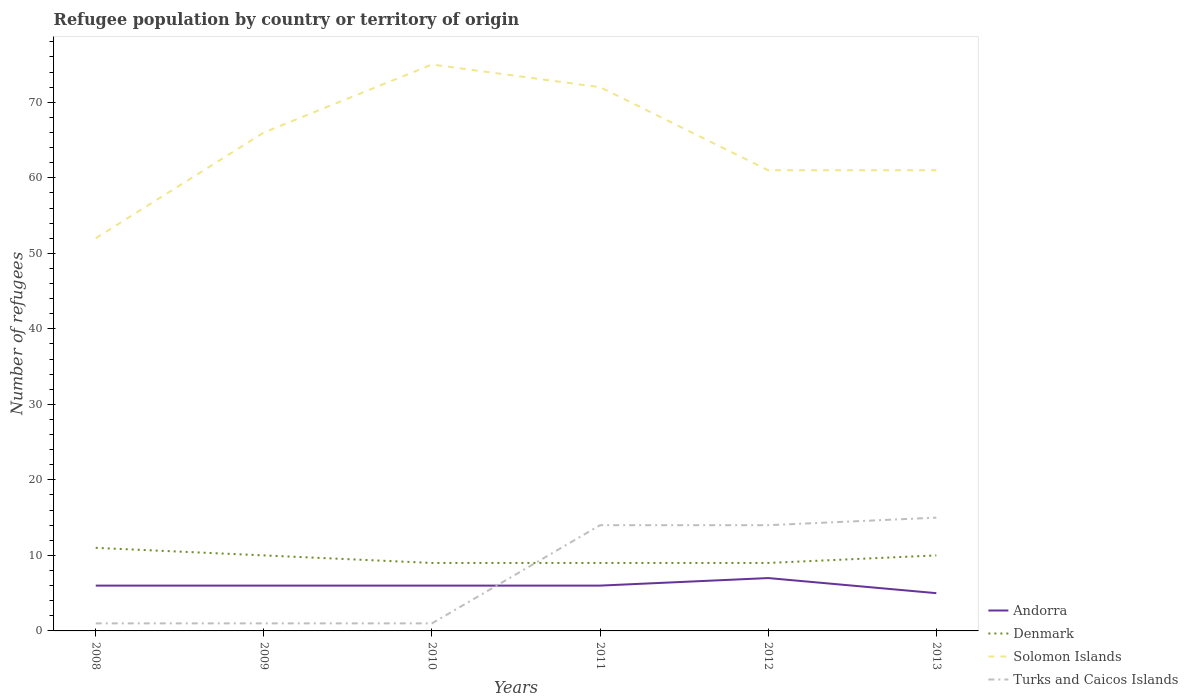Across all years, what is the maximum number of refugees in Turks and Caicos Islands?
Offer a terse response. 1. What is the difference between the highest and the lowest number of refugees in Turks and Caicos Islands?
Offer a terse response. 3. How many years are there in the graph?
Offer a very short reply. 6. What is the difference between two consecutive major ticks on the Y-axis?
Your answer should be compact. 10. How many legend labels are there?
Make the answer very short. 4. How are the legend labels stacked?
Offer a very short reply. Vertical. What is the title of the graph?
Ensure brevity in your answer.  Refugee population by country or territory of origin. What is the label or title of the X-axis?
Your response must be concise. Years. What is the label or title of the Y-axis?
Your answer should be compact. Number of refugees. What is the Number of refugees of Denmark in 2009?
Your answer should be compact. 10. What is the Number of refugees of Solomon Islands in 2009?
Your response must be concise. 66. What is the Number of refugees in Turks and Caicos Islands in 2009?
Your answer should be very brief. 1. What is the Number of refugees in Andorra in 2010?
Give a very brief answer. 6. What is the Number of refugees of Denmark in 2010?
Ensure brevity in your answer.  9. What is the Number of refugees in Solomon Islands in 2010?
Keep it short and to the point. 75. What is the Number of refugees in Andorra in 2011?
Make the answer very short. 6. What is the Number of refugees of Andorra in 2012?
Give a very brief answer. 7. What is the Number of refugees in Denmark in 2012?
Offer a terse response. 9. What is the Number of refugees of Solomon Islands in 2012?
Offer a terse response. 61. What is the Number of refugees in Turks and Caicos Islands in 2013?
Offer a very short reply. 15. Across all years, what is the maximum Number of refugees of Denmark?
Your answer should be compact. 11. Across all years, what is the maximum Number of refugees in Turks and Caicos Islands?
Provide a succinct answer. 15. Across all years, what is the minimum Number of refugees in Andorra?
Keep it short and to the point. 5. Across all years, what is the minimum Number of refugees of Solomon Islands?
Your answer should be compact. 52. Across all years, what is the minimum Number of refugees of Turks and Caicos Islands?
Keep it short and to the point. 1. What is the total Number of refugees of Andorra in the graph?
Keep it short and to the point. 36. What is the total Number of refugees of Solomon Islands in the graph?
Keep it short and to the point. 387. What is the total Number of refugees in Turks and Caicos Islands in the graph?
Provide a succinct answer. 46. What is the difference between the Number of refugees in Denmark in 2008 and that in 2009?
Offer a very short reply. 1. What is the difference between the Number of refugees of Solomon Islands in 2008 and that in 2009?
Make the answer very short. -14. What is the difference between the Number of refugees in Andorra in 2008 and that in 2010?
Your answer should be compact. 0. What is the difference between the Number of refugees of Solomon Islands in 2008 and that in 2010?
Give a very brief answer. -23. What is the difference between the Number of refugees in Andorra in 2008 and that in 2011?
Offer a very short reply. 0. What is the difference between the Number of refugees of Denmark in 2008 and that in 2011?
Make the answer very short. 2. What is the difference between the Number of refugees of Solomon Islands in 2008 and that in 2011?
Your response must be concise. -20. What is the difference between the Number of refugees in Turks and Caicos Islands in 2008 and that in 2011?
Give a very brief answer. -13. What is the difference between the Number of refugees in Andorra in 2008 and that in 2012?
Provide a succinct answer. -1. What is the difference between the Number of refugees of Solomon Islands in 2008 and that in 2012?
Provide a short and direct response. -9. What is the difference between the Number of refugees in Turks and Caicos Islands in 2008 and that in 2012?
Your answer should be compact. -13. What is the difference between the Number of refugees of Andorra in 2008 and that in 2013?
Keep it short and to the point. 1. What is the difference between the Number of refugees of Denmark in 2008 and that in 2013?
Your response must be concise. 1. What is the difference between the Number of refugees of Turks and Caicos Islands in 2008 and that in 2013?
Provide a short and direct response. -14. What is the difference between the Number of refugees in Andorra in 2009 and that in 2010?
Offer a terse response. 0. What is the difference between the Number of refugees of Denmark in 2009 and that in 2010?
Keep it short and to the point. 1. What is the difference between the Number of refugees of Andorra in 2009 and that in 2012?
Give a very brief answer. -1. What is the difference between the Number of refugees in Andorra in 2009 and that in 2013?
Offer a very short reply. 1. What is the difference between the Number of refugees of Solomon Islands in 2009 and that in 2013?
Give a very brief answer. 5. What is the difference between the Number of refugees in Turks and Caicos Islands in 2009 and that in 2013?
Keep it short and to the point. -14. What is the difference between the Number of refugees of Solomon Islands in 2010 and that in 2011?
Your answer should be very brief. 3. What is the difference between the Number of refugees in Turks and Caicos Islands in 2010 and that in 2011?
Offer a very short reply. -13. What is the difference between the Number of refugees of Turks and Caicos Islands in 2010 and that in 2012?
Provide a short and direct response. -13. What is the difference between the Number of refugees in Denmark in 2010 and that in 2013?
Your response must be concise. -1. What is the difference between the Number of refugees in Turks and Caicos Islands in 2010 and that in 2013?
Offer a terse response. -14. What is the difference between the Number of refugees in Andorra in 2011 and that in 2012?
Provide a short and direct response. -1. What is the difference between the Number of refugees of Denmark in 2011 and that in 2012?
Your answer should be very brief. 0. What is the difference between the Number of refugees of Andorra in 2011 and that in 2013?
Offer a very short reply. 1. What is the difference between the Number of refugees in Turks and Caicos Islands in 2011 and that in 2013?
Make the answer very short. -1. What is the difference between the Number of refugees of Andorra in 2012 and that in 2013?
Give a very brief answer. 2. What is the difference between the Number of refugees of Solomon Islands in 2012 and that in 2013?
Offer a terse response. 0. What is the difference between the Number of refugees in Andorra in 2008 and the Number of refugees in Solomon Islands in 2009?
Ensure brevity in your answer.  -60. What is the difference between the Number of refugees of Denmark in 2008 and the Number of refugees of Solomon Islands in 2009?
Offer a very short reply. -55. What is the difference between the Number of refugees in Denmark in 2008 and the Number of refugees in Turks and Caicos Islands in 2009?
Give a very brief answer. 10. What is the difference between the Number of refugees of Andorra in 2008 and the Number of refugees of Solomon Islands in 2010?
Offer a very short reply. -69. What is the difference between the Number of refugees in Andorra in 2008 and the Number of refugees in Turks and Caicos Islands in 2010?
Keep it short and to the point. 5. What is the difference between the Number of refugees of Denmark in 2008 and the Number of refugees of Solomon Islands in 2010?
Provide a succinct answer. -64. What is the difference between the Number of refugees in Solomon Islands in 2008 and the Number of refugees in Turks and Caicos Islands in 2010?
Provide a short and direct response. 51. What is the difference between the Number of refugees of Andorra in 2008 and the Number of refugees of Solomon Islands in 2011?
Your answer should be compact. -66. What is the difference between the Number of refugees in Denmark in 2008 and the Number of refugees in Solomon Islands in 2011?
Ensure brevity in your answer.  -61. What is the difference between the Number of refugees in Denmark in 2008 and the Number of refugees in Turks and Caicos Islands in 2011?
Offer a very short reply. -3. What is the difference between the Number of refugees of Andorra in 2008 and the Number of refugees of Solomon Islands in 2012?
Provide a succinct answer. -55. What is the difference between the Number of refugees of Denmark in 2008 and the Number of refugees of Solomon Islands in 2012?
Provide a short and direct response. -50. What is the difference between the Number of refugees in Denmark in 2008 and the Number of refugees in Turks and Caicos Islands in 2012?
Your response must be concise. -3. What is the difference between the Number of refugees in Andorra in 2008 and the Number of refugees in Denmark in 2013?
Provide a succinct answer. -4. What is the difference between the Number of refugees of Andorra in 2008 and the Number of refugees of Solomon Islands in 2013?
Your response must be concise. -55. What is the difference between the Number of refugees in Denmark in 2008 and the Number of refugees in Turks and Caicos Islands in 2013?
Make the answer very short. -4. What is the difference between the Number of refugees in Andorra in 2009 and the Number of refugees in Denmark in 2010?
Ensure brevity in your answer.  -3. What is the difference between the Number of refugees of Andorra in 2009 and the Number of refugees of Solomon Islands in 2010?
Provide a succinct answer. -69. What is the difference between the Number of refugees in Andorra in 2009 and the Number of refugees in Turks and Caicos Islands in 2010?
Provide a succinct answer. 5. What is the difference between the Number of refugees of Denmark in 2009 and the Number of refugees of Solomon Islands in 2010?
Provide a short and direct response. -65. What is the difference between the Number of refugees in Andorra in 2009 and the Number of refugees in Denmark in 2011?
Offer a terse response. -3. What is the difference between the Number of refugees of Andorra in 2009 and the Number of refugees of Solomon Islands in 2011?
Your answer should be very brief. -66. What is the difference between the Number of refugees in Andorra in 2009 and the Number of refugees in Turks and Caicos Islands in 2011?
Give a very brief answer. -8. What is the difference between the Number of refugees in Denmark in 2009 and the Number of refugees in Solomon Islands in 2011?
Make the answer very short. -62. What is the difference between the Number of refugees in Denmark in 2009 and the Number of refugees in Turks and Caicos Islands in 2011?
Provide a short and direct response. -4. What is the difference between the Number of refugees in Andorra in 2009 and the Number of refugees in Solomon Islands in 2012?
Keep it short and to the point. -55. What is the difference between the Number of refugees in Denmark in 2009 and the Number of refugees in Solomon Islands in 2012?
Ensure brevity in your answer.  -51. What is the difference between the Number of refugees of Denmark in 2009 and the Number of refugees of Turks and Caicos Islands in 2012?
Offer a very short reply. -4. What is the difference between the Number of refugees in Andorra in 2009 and the Number of refugees in Denmark in 2013?
Your response must be concise. -4. What is the difference between the Number of refugees of Andorra in 2009 and the Number of refugees of Solomon Islands in 2013?
Provide a short and direct response. -55. What is the difference between the Number of refugees in Denmark in 2009 and the Number of refugees in Solomon Islands in 2013?
Offer a very short reply. -51. What is the difference between the Number of refugees in Denmark in 2009 and the Number of refugees in Turks and Caicos Islands in 2013?
Offer a terse response. -5. What is the difference between the Number of refugees in Solomon Islands in 2009 and the Number of refugees in Turks and Caicos Islands in 2013?
Offer a terse response. 51. What is the difference between the Number of refugees in Andorra in 2010 and the Number of refugees in Denmark in 2011?
Your response must be concise. -3. What is the difference between the Number of refugees of Andorra in 2010 and the Number of refugees of Solomon Islands in 2011?
Make the answer very short. -66. What is the difference between the Number of refugees in Denmark in 2010 and the Number of refugees in Solomon Islands in 2011?
Your answer should be compact. -63. What is the difference between the Number of refugees in Solomon Islands in 2010 and the Number of refugees in Turks and Caicos Islands in 2011?
Your answer should be compact. 61. What is the difference between the Number of refugees of Andorra in 2010 and the Number of refugees of Solomon Islands in 2012?
Ensure brevity in your answer.  -55. What is the difference between the Number of refugees of Andorra in 2010 and the Number of refugees of Turks and Caicos Islands in 2012?
Your answer should be compact. -8. What is the difference between the Number of refugees in Denmark in 2010 and the Number of refugees in Solomon Islands in 2012?
Provide a succinct answer. -52. What is the difference between the Number of refugees of Denmark in 2010 and the Number of refugees of Turks and Caicos Islands in 2012?
Offer a terse response. -5. What is the difference between the Number of refugees in Andorra in 2010 and the Number of refugees in Denmark in 2013?
Provide a succinct answer. -4. What is the difference between the Number of refugees in Andorra in 2010 and the Number of refugees in Solomon Islands in 2013?
Give a very brief answer. -55. What is the difference between the Number of refugees in Andorra in 2010 and the Number of refugees in Turks and Caicos Islands in 2013?
Make the answer very short. -9. What is the difference between the Number of refugees of Denmark in 2010 and the Number of refugees of Solomon Islands in 2013?
Your answer should be compact. -52. What is the difference between the Number of refugees of Denmark in 2010 and the Number of refugees of Turks and Caicos Islands in 2013?
Offer a very short reply. -6. What is the difference between the Number of refugees of Andorra in 2011 and the Number of refugees of Denmark in 2012?
Offer a very short reply. -3. What is the difference between the Number of refugees of Andorra in 2011 and the Number of refugees of Solomon Islands in 2012?
Provide a short and direct response. -55. What is the difference between the Number of refugees in Denmark in 2011 and the Number of refugees in Solomon Islands in 2012?
Provide a short and direct response. -52. What is the difference between the Number of refugees in Solomon Islands in 2011 and the Number of refugees in Turks and Caicos Islands in 2012?
Offer a terse response. 58. What is the difference between the Number of refugees in Andorra in 2011 and the Number of refugees in Solomon Islands in 2013?
Your response must be concise. -55. What is the difference between the Number of refugees in Andorra in 2011 and the Number of refugees in Turks and Caicos Islands in 2013?
Your answer should be compact. -9. What is the difference between the Number of refugees of Denmark in 2011 and the Number of refugees of Solomon Islands in 2013?
Keep it short and to the point. -52. What is the difference between the Number of refugees in Solomon Islands in 2011 and the Number of refugees in Turks and Caicos Islands in 2013?
Provide a short and direct response. 57. What is the difference between the Number of refugees of Andorra in 2012 and the Number of refugees of Denmark in 2013?
Your answer should be very brief. -3. What is the difference between the Number of refugees in Andorra in 2012 and the Number of refugees in Solomon Islands in 2013?
Your response must be concise. -54. What is the difference between the Number of refugees in Andorra in 2012 and the Number of refugees in Turks and Caicos Islands in 2013?
Give a very brief answer. -8. What is the difference between the Number of refugees in Denmark in 2012 and the Number of refugees in Solomon Islands in 2013?
Your answer should be compact. -52. What is the difference between the Number of refugees in Solomon Islands in 2012 and the Number of refugees in Turks and Caicos Islands in 2013?
Give a very brief answer. 46. What is the average Number of refugees of Denmark per year?
Your answer should be very brief. 9.67. What is the average Number of refugees in Solomon Islands per year?
Make the answer very short. 64.5. What is the average Number of refugees of Turks and Caicos Islands per year?
Your response must be concise. 7.67. In the year 2008, what is the difference between the Number of refugees of Andorra and Number of refugees of Solomon Islands?
Ensure brevity in your answer.  -46. In the year 2008, what is the difference between the Number of refugees of Denmark and Number of refugees of Solomon Islands?
Provide a succinct answer. -41. In the year 2009, what is the difference between the Number of refugees in Andorra and Number of refugees in Denmark?
Provide a short and direct response. -4. In the year 2009, what is the difference between the Number of refugees of Andorra and Number of refugees of Solomon Islands?
Provide a succinct answer. -60. In the year 2009, what is the difference between the Number of refugees of Denmark and Number of refugees of Solomon Islands?
Provide a short and direct response. -56. In the year 2009, what is the difference between the Number of refugees of Denmark and Number of refugees of Turks and Caicos Islands?
Keep it short and to the point. 9. In the year 2010, what is the difference between the Number of refugees in Andorra and Number of refugees in Denmark?
Give a very brief answer. -3. In the year 2010, what is the difference between the Number of refugees in Andorra and Number of refugees in Solomon Islands?
Your answer should be very brief. -69. In the year 2010, what is the difference between the Number of refugees of Andorra and Number of refugees of Turks and Caicos Islands?
Your answer should be compact. 5. In the year 2010, what is the difference between the Number of refugees in Denmark and Number of refugees in Solomon Islands?
Your answer should be compact. -66. In the year 2010, what is the difference between the Number of refugees of Solomon Islands and Number of refugees of Turks and Caicos Islands?
Make the answer very short. 74. In the year 2011, what is the difference between the Number of refugees in Andorra and Number of refugees in Denmark?
Your response must be concise. -3. In the year 2011, what is the difference between the Number of refugees of Andorra and Number of refugees of Solomon Islands?
Provide a short and direct response. -66. In the year 2011, what is the difference between the Number of refugees in Denmark and Number of refugees in Solomon Islands?
Make the answer very short. -63. In the year 2011, what is the difference between the Number of refugees in Denmark and Number of refugees in Turks and Caicos Islands?
Provide a succinct answer. -5. In the year 2011, what is the difference between the Number of refugees in Solomon Islands and Number of refugees in Turks and Caicos Islands?
Keep it short and to the point. 58. In the year 2012, what is the difference between the Number of refugees of Andorra and Number of refugees of Denmark?
Give a very brief answer. -2. In the year 2012, what is the difference between the Number of refugees of Andorra and Number of refugees of Solomon Islands?
Offer a very short reply. -54. In the year 2012, what is the difference between the Number of refugees in Andorra and Number of refugees in Turks and Caicos Islands?
Your answer should be compact. -7. In the year 2012, what is the difference between the Number of refugees of Denmark and Number of refugees of Solomon Islands?
Keep it short and to the point. -52. In the year 2012, what is the difference between the Number of refugees in Denmark and Number of refugees in Turks and Caicos Islands?
Offer a very short reply. -5. In the year 2012, what is the difference between the Number of refugees in Solomon Islands and Number of refugees in Turks and Caicos Islands?
Your response must be concise. 47. In the year 2013, what is the difference between the Number of refugees in Andorra and Number of refugees in Solomon Islands?
Provide a succinct answer. -56. In the year 2013, what is the difference between the Number of refugees of Andorra and Number of refugees of Turks and Caicos Islands?
Ensure brevity in your answer.  -10. In the year 2013, what is the difference between the Number of refugees of Denmark and Number of refugees of Solomon Islands?
Give a very brief answer. -51. In the year 2013, what is the difference between the Number of refugees of Denmark and Number of refugees of Turks and Caicos Islands?
Provide a short and direct response. -5. In the year 2013, what is the difference between the Number of refugees of Solomon Islands and Number of refugees of Turks and Caicos Islands?
Your answer should be very brief. 46. What is the ratio of the Number of refugees in Solomon Islands in 2008 to that in 2009?
Keep it short and to the point. 0.79. What is the ratio of the Number of refugees in Denmark in 2008 to that in 2010?
Your answer should be compact. 1.22. What is the ratio of the Number of refugees of Solomon Islands in 2008 to that in 2010?
Provide a short and direct response. 0.69. What is the ratio of the Number of refugees in Andorra in 2008 to that in 2011?
Keep it short and to the point. 1. What is the ratio of the Number of refugees in Denmark in 2008 to that in 2011?
Offer a terse response. 1.22. What is the ratio of the Number of refugees in Solomon Islands in 2008 to that in 2011?
Your answer should be very brief. 0.72. What is the ratio of the Number of refugees of Turks and Caicos Islands in 2008 to that in 2011?
Offer a very short reply. 0.07. What is the ratio of the Number of refugees in Denmark in 2008 to that in 2012?
Give a very brief answer. 1.22. What is the ratio of the Number of refugees of Solomon Islands in 2008 to that in 2012?
Keep it short and to the point. 0.85. What is the ratio of the Number of refugees in Turks and Caicos Islands in 2008 to that in 2012?
Provide a succinct answer. 0.07. What is the ratio of the Number of refugees of Andorra in 2008 to that in 2013?
Ensure brevity in your answer.  1.2. What is the ratio of the Number of refugees in Solomon Islands in 2008 to that in 2013?
Provide a short and direct response. 0.85. What is the ratio of the Number of refugees of Turks and Caicos Islands in 2008 to that in 2013?
Ensure brevity in your answer.  0.07. What is the ratio of the Number of refugees in Denmark in 2009 to that in 2010?
Your answer should be compact. 1.11. What is the ratio of the Number of refugees of Solomon Islands in 2009 to that in 2011?
Your answer should be very brief. 0.92. What is the ratio of the Number of refugees of Turks and Caicos Islands in 2009 to that in 2011?
Offer a terse response. 0.07. What is the ratio of the Number of refugees in Denmark in 2009 to that in 2012?
Ensure brevity in your answer.  1.11. What is the ratio of the Number of refugees of Solomon Islands in 2009 to that in 2012?
Provide a succinct answer. 1.08. What is the ratio of the Number of refugees of Turks and Caicos Islands in 2009 to that in 2012?
Offer a terse response. 0.07. What is the ratio of the Number of refugees in Solomon Islands in 2009 to that in 2013?
Offer a terse response. 1.08. What is the ratio of the Number of refugees of Turks and Caicos Islands in 2009 to that in 2013?
Ensure brevity in your answer.  0.07. What is the ratio of the Number of refugees of Andorra in 2010 to that in 2011?
Make the answer very short. 1. What is the ratio of the Number of refugees of Solomon Islands in 2010 to that in 2011?
Provide a short and direct response. 1.04. What is the ratio of the Number of refugees of Turks and Caicos Islands in 2010 to that in 2011?
Offer a terse response. 0.07. What is the ratio of the Number of refugees of Andorra in 2010 to that in 2012?
Give a very brief answer. 0.86. What is the ratio of the Number of refugees in Denmark in 2010 to that in 2012?
Make the answer very short. 1. What is the ratio of the Number of refugees of Solomon Islands in 2010 to that in 2012?
Provide a succinct answer. 1.23. What is the ratio of the Number of refugees in Turks and Caicos Islands in 2010 to that in 2012?
Your answer should be very brief. 0.07. What is the ratio of the Number of refugees of Andorra in 2010 to that in 2013?
Ensure brevity in your answer.  1.2. What is the ratio of the Number of refugees in Solomon Islands in 2010 to that in 2013?
Keep it short and to the point. 1.23. What is the ratio of the Number of refugees in Turks and Caicos Islands in 2010 to that in 2013?
Your response must be concise. 0.07. What is the ratio of the Number of refugees of Solomon Islands in 2011 to that in 2012?
Offer a terse response. 1.18. What is the ratio of the Number of refugees in Solomon Islands in 2011 to that in 2013?
Your answer should be very brief. 1.18. What is the ratio of the Number of refugees of Denmark in 2012 to that in 2013?
Make the answer very short. 0.9. What is the difference between the highest and the second highest Number of refugees in Andorra?
Your answer should be very brief. 1. What is the difference between the highest and the second highest Number of refugees of Solomon Islands?
Provide a short and direct response. 3. What is the difference between the highest and the lowest Number of refugees of Andorra?
Give a very brief answer. 2. What is the difference between the highest and the lowest Number of refugees of Denmark?
Provide a short and direct response. 2. 